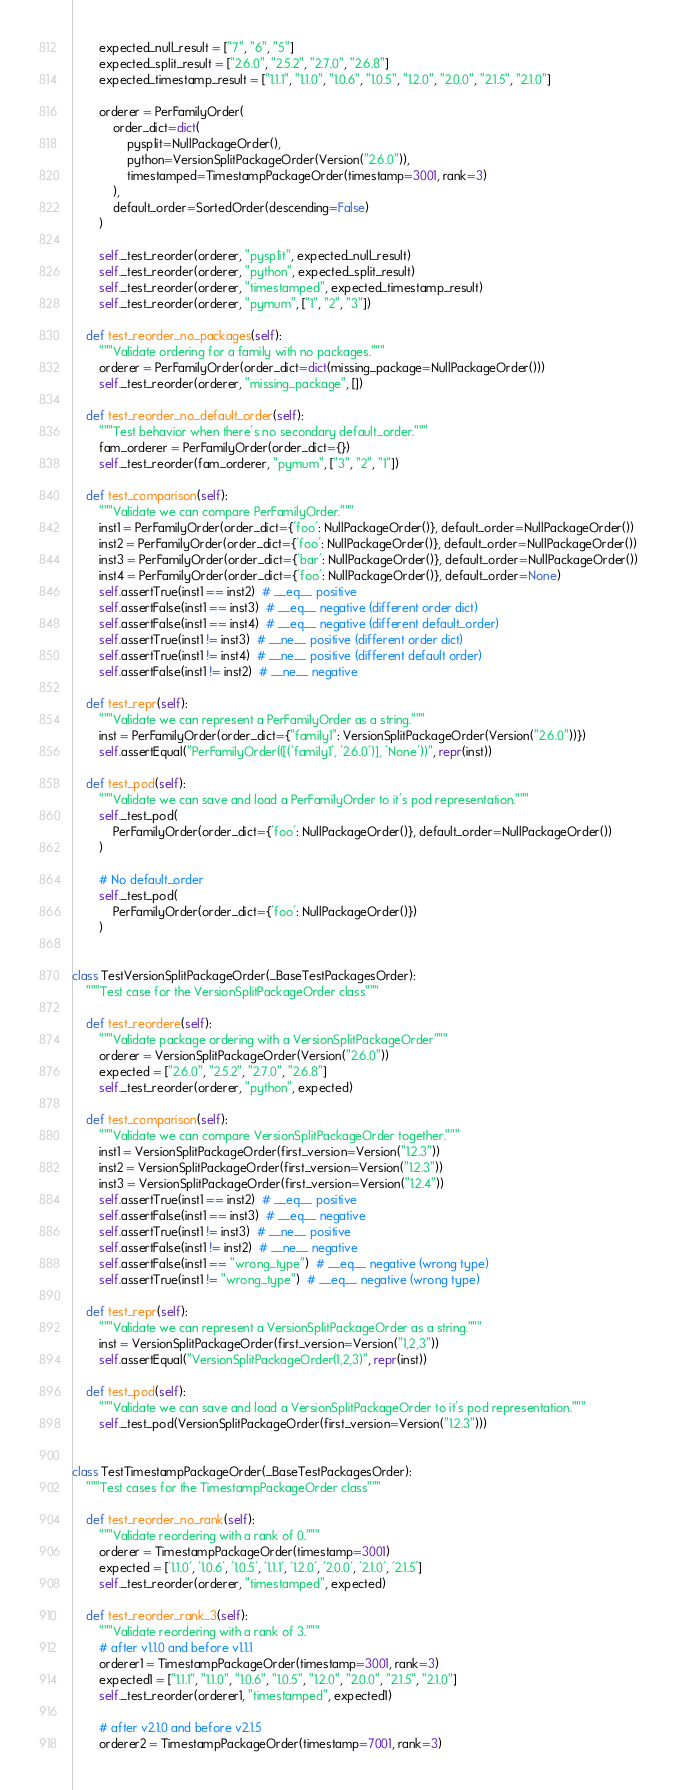Convert code to text. <code><loc_0><loc_0><loc_500><loc_500><_Python_>        expected_null_result = ["7", "6", "5"]
        expected_split_result = ["2.6.0", "2.5.2", "2.7.0", "2.6.8"]
        expected_timestamp_result = ["1.1.1", "1.1.0", "1.0.6", "1.0.5", "1.2.0", "2.0.0", "2.1.5", "2.1.0"]

        orderer = PerFamilyOrder(
            order_dict=dict(
                pysplit=NullPackageOrder(),
                python=VersionSplitPackageOrder(Version("2.6.0")),
                timestamped=TimestampPackageOrder(timestamp=3001, rank=3)
            ),
            default_order=SortedOrder(descending=False)
        )

        self._test_reorder(orderer, "pysplit", expected_null_result)
        self._test_reorder(orderer, "python", expected_split_result)
        self._test_reorder(orderer, "timestamped", expected_timestamp_result)
        self._test_reorder(orderer, "pymum", ["1", "2", "3"])

    def test_reorder_no_packages(self):
        """Validate ordering for a family with no packages."""
        orderer = PerFamilyOrder(order_dict=dict(missing_package=NullPackageOrder()))
        self._test_reorder(orderer, "missing_package", [])

    def test_reorder_no_default_order(self):
        """Test behavior when there's no secondary default_order."""
        fam_orderer = PerFamilyOrder(order_dict={})
        self._test_reorder(fam_orderer, "pymum", ["3", "2", "1"])

    def test_comparison(self):
        """Validate we can compare PerFamilyOrder."""
        inst1 = PerFamilyOrder(order_dict={'foo': NullPackageOrder()}, default_order=NullPackageOrder())
        inst2 = PerFamilyOrder(order_dict={'foo': NullPackageOrder()}, default_order=NullPackageOrder())
        inst3 = PerFamilyOrder(order_dict={'bar': NullPackageOrder()}, default_order=NullPackageOrder())
        inst4 = PerFamilyOrder(order_dict={'foo': NullPackageOrder()}, default_order=None)
        self.assertTrue(inst1 == inst2)  # __eq__ positive
        self.assertFalse(inst1 == inst3)  # __eq__ negative (different order dict)
        self.assertFalse(inst1 == inst4)  # __eq__ negative (different default_order)
        self.assertTrue(inst1 != inst3)  # __ne__ positive (different order dict)
        self.assertTrue(inst1 != inst4)  # __ne__ positive (different default order)
        self.assertFalse(inst1 != inst2)  # __ne__ negative

    def test_repr(self):
        """Validate we can represent a PerFamilyOrder as a string."""
        inst = PerFamilyOrder(order_dict={"family1": VersionSplitPackageOrder(Version("2.6.0"))})
        self.assertEqual("PerFamilyOrder(([('family1', '2.6.0')], 'None'))", repr(inst))

    def test_pod(self):
        """Validate we can save and load a PerFamilyOrder to it's pod representation."""
        self._test_pod(
            PerFamilyOrder(order_dict={'foo': NullPackageOrder()}, default_order=NullPackageOrder())
        )

        # No default_order
        self._test_pod(
            PerFamilyOrder(order_dict={'foo': NullPackageOrder()})
        )


class TestVersionSplitPackageOrder(_BaseTestPackagesOrder):
    """Test case for the VersionSplitPackageOrder class"""

    def test_reordere(self):
        """Validate package ordering with a VersionSplitPackageOrder"""
        orderer = VersionSplitPackageOrder(Version("2.6.0"))
        expected = ["2.6.0", "2.5.2", "2.7.0", "2.6.8"]
        self._test_reorder(orderer, "python", expected)

    def test_comparison(self):
        """Validate we can compare VersionSplitPackageOrder together."""
        inst1 = VersionSplitPackageOrder(first_version=Version("1.2.3"))
        inst2 = VersionSplitPackageOrder(first_version=Version("1.2.3"))
        inst3 = VersionSplitPackageOrder(first_version=Version("1.2.4"))
        self.assertTrue(inst1 == inst2)  # __eq__ positive
        self.assertFalse(inst1 == inst3)  # __eq__ negative
        self.assertTrue(inst1 != inst3)  # __ne__ positive
        self.assertFalse(inst1 != inst2)  # __ne__ negative
        self.assertFalse(inst1 == "wrong_type")  # __eq__ negative (wrong type)
        self.assertTrue(inst1 != "wrong_type")  # __eq__ negative (wrong type)

    def test_repr(self):
        """Validate we can represent a VersionSplitPackageOrder as a string."""
        inst = VersionSplitPackageOrder(first_version=Version("1,2,3"))
        self.assertEqual("VersionSplitPackageOrder(1,2,3)", repr(inst))

    def test_pod(self):
        """Validate we can save and load a VersionSplitPackageOrder to it's pod representation."""
        self._test_pod(VersionSplitPackageOrder(first_version=Version("1.2.3")))


class TestTimestampPackageOrder(_BaseTestPackagesOrder):
    """Test cases for the TimestampPackageOrder class"""

    def test_reorder_no_rank(self):
        """Validate reordering with a rank of 0."""
        orderer = TimestampPackageOrder(timestamp=3001)
        expected = ['1.1.0', '1.0.6', '1.0.5', '1.1.1', '1.2.0', '2.0.0', '2.1.0', '2.1.5']
        self._test_reorder(orderer, "timestamped", expected)

    def test_reorder_rank_3(self):
        """Validate reordering with a rank of 3."""
        # after v1.1.0 and before v1.1.1
        orderer1 = TimestampPackageOrder(timestamp=3001, rank=3)
        expected1 = ["1.1.1", "1.1.0", "1.0.6", "1.0.5", "1.2.0", "2.0.0", "2.1.5", "2.1.0"]
        self._test_reorder(orderer1, "timestamped", expected1)

        # after v2.1.0 and before v2.1.5
        orderer2 = TimestampPackageOrder(timestamp=7001, rank=3)</code> 